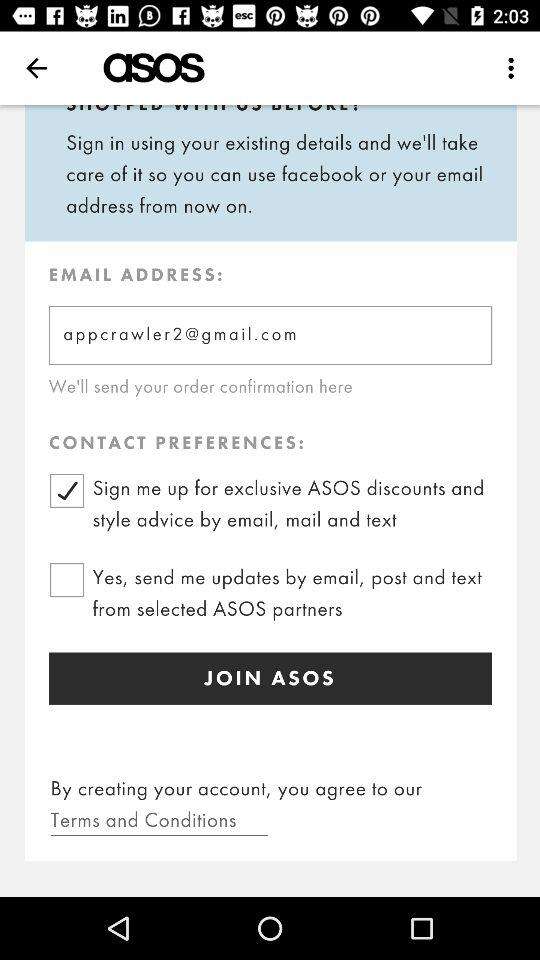What is the app title? The app title is "asos". 